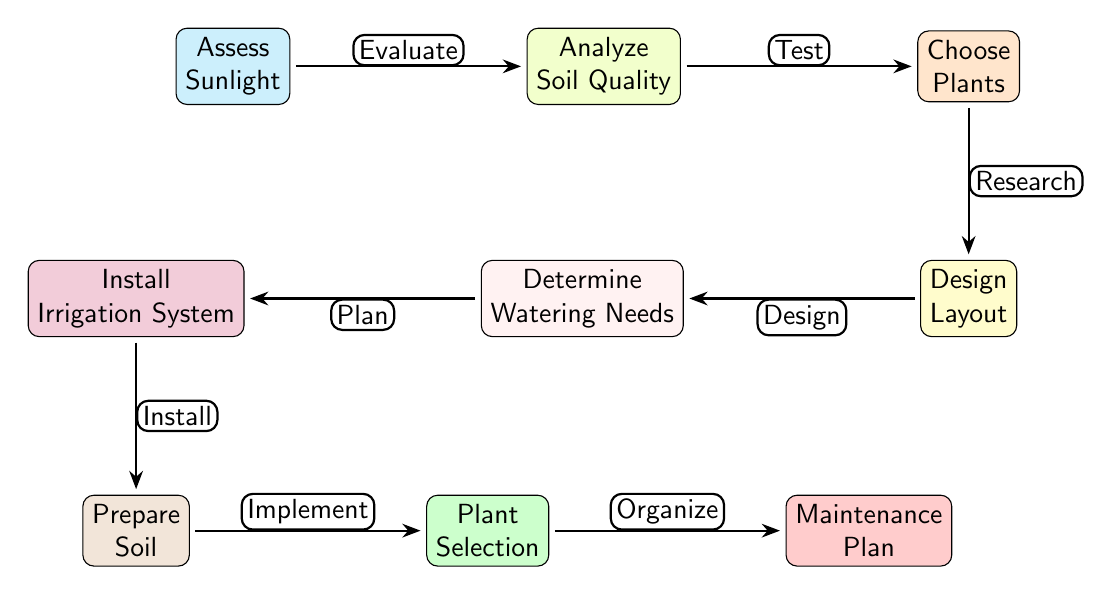What is the first step in the garden design planning process? The first node in the diagram is "Assess Sunlight," which represents the initial step in planning a garden.
Answer: Assess Sunlight How many nodes are there in the diagram? Counting all the nodes in the diagram, we have a total of nine nodes representing different steps in garden design planning.
Answer: Nine What is the last step that follows "Plant Selection"? After "Plant Selection," the next step is "Maintenance Plan," which is indicated as the final node in the flow of the diagram.
Answer: Maintenance Plan Which two steps are connected by the label "Test"? The nodes "Analyze Soil Quality" and "Choose Plants" are connected by the label "Test," indicating the relationship between evaluating soil quality and selecting plants.
Answer: Analyze Soil Quality and Choose Plants What action follows determining watering needs? After "Determine Watering Needs," the next action is "Install Irrigation System," showing the progression from planning watering to implementing the system.
Answer: Install Irrigation System What shape is used for all the nodes in the diagram? All nodes in the diagram are drawn as rounded rectangles, which gives a uniform appearance to the individual steps in the process.
Answer: Rounded rectangles Which step directly precedes "Design Layout"? The step that directly precedes "Design Layout" is "Choose Plants," as indicated by the flow of connections visible in the diagram.
Answer: Choose Plants What kind of action is represented by the edge between "Prepare Soil" and "Plant Selection"? The action represented by the edge is "Implement," showing that preparing the soil leads directly to selecting plants for the garden.
Answer: Implement What is the color of the node for "Install Irrigation System"? The color of the node for "Install Irrigation System" is purple, indicating a distinct visual representation for this specific step.
Answer: Purple 